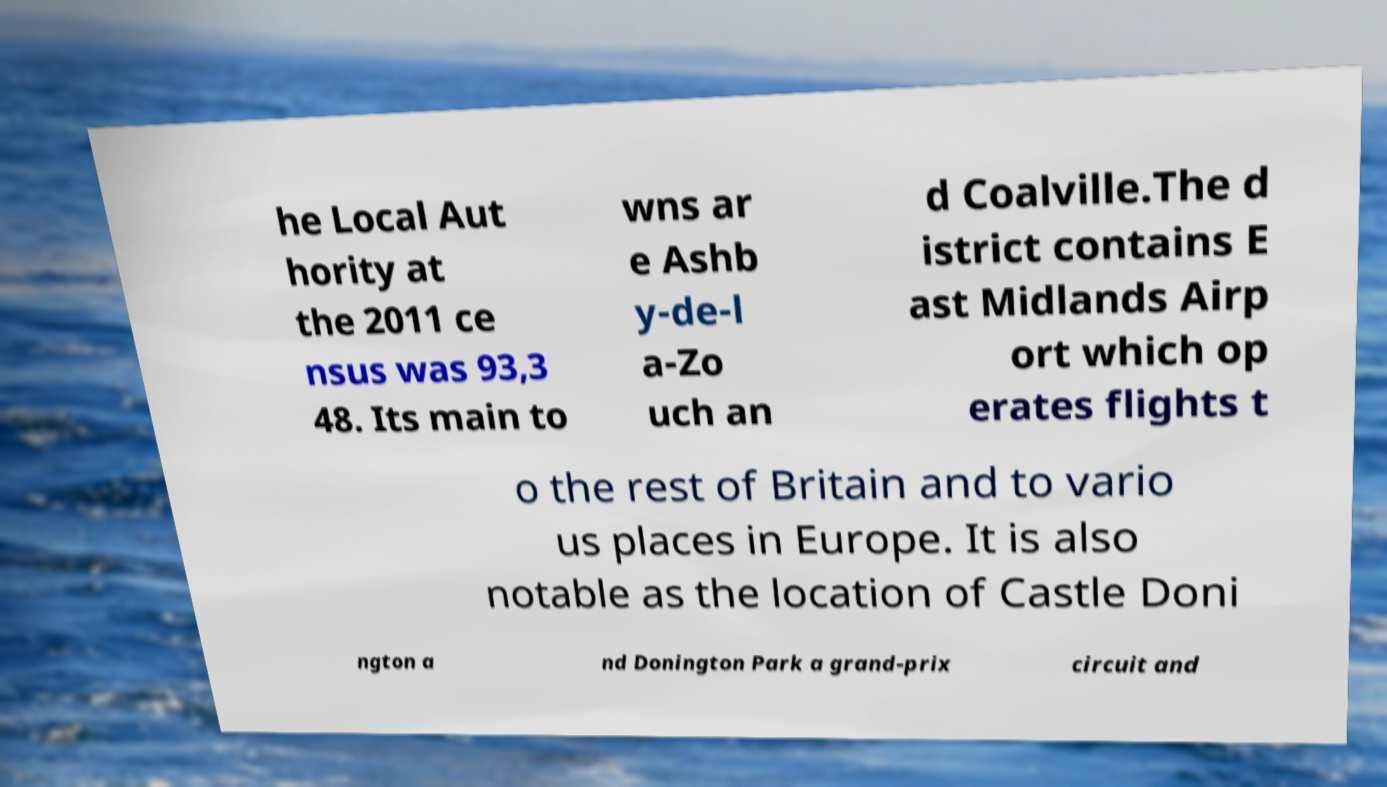Please identify and transcribe the text found in this image. he Local Aut hority at the 2011 ce nsus was 93,3 48. Its main to wns ar e Ashb y-de-l a-Zo uch an d Coalville.The d istrict contains E ast Midlands Airp ort which op erates flights t o the rest of Britain and to vario us places in Europe. It is also notable as the location of Castle Doni ngton a nd Donington Park a grand-prix circuit and 